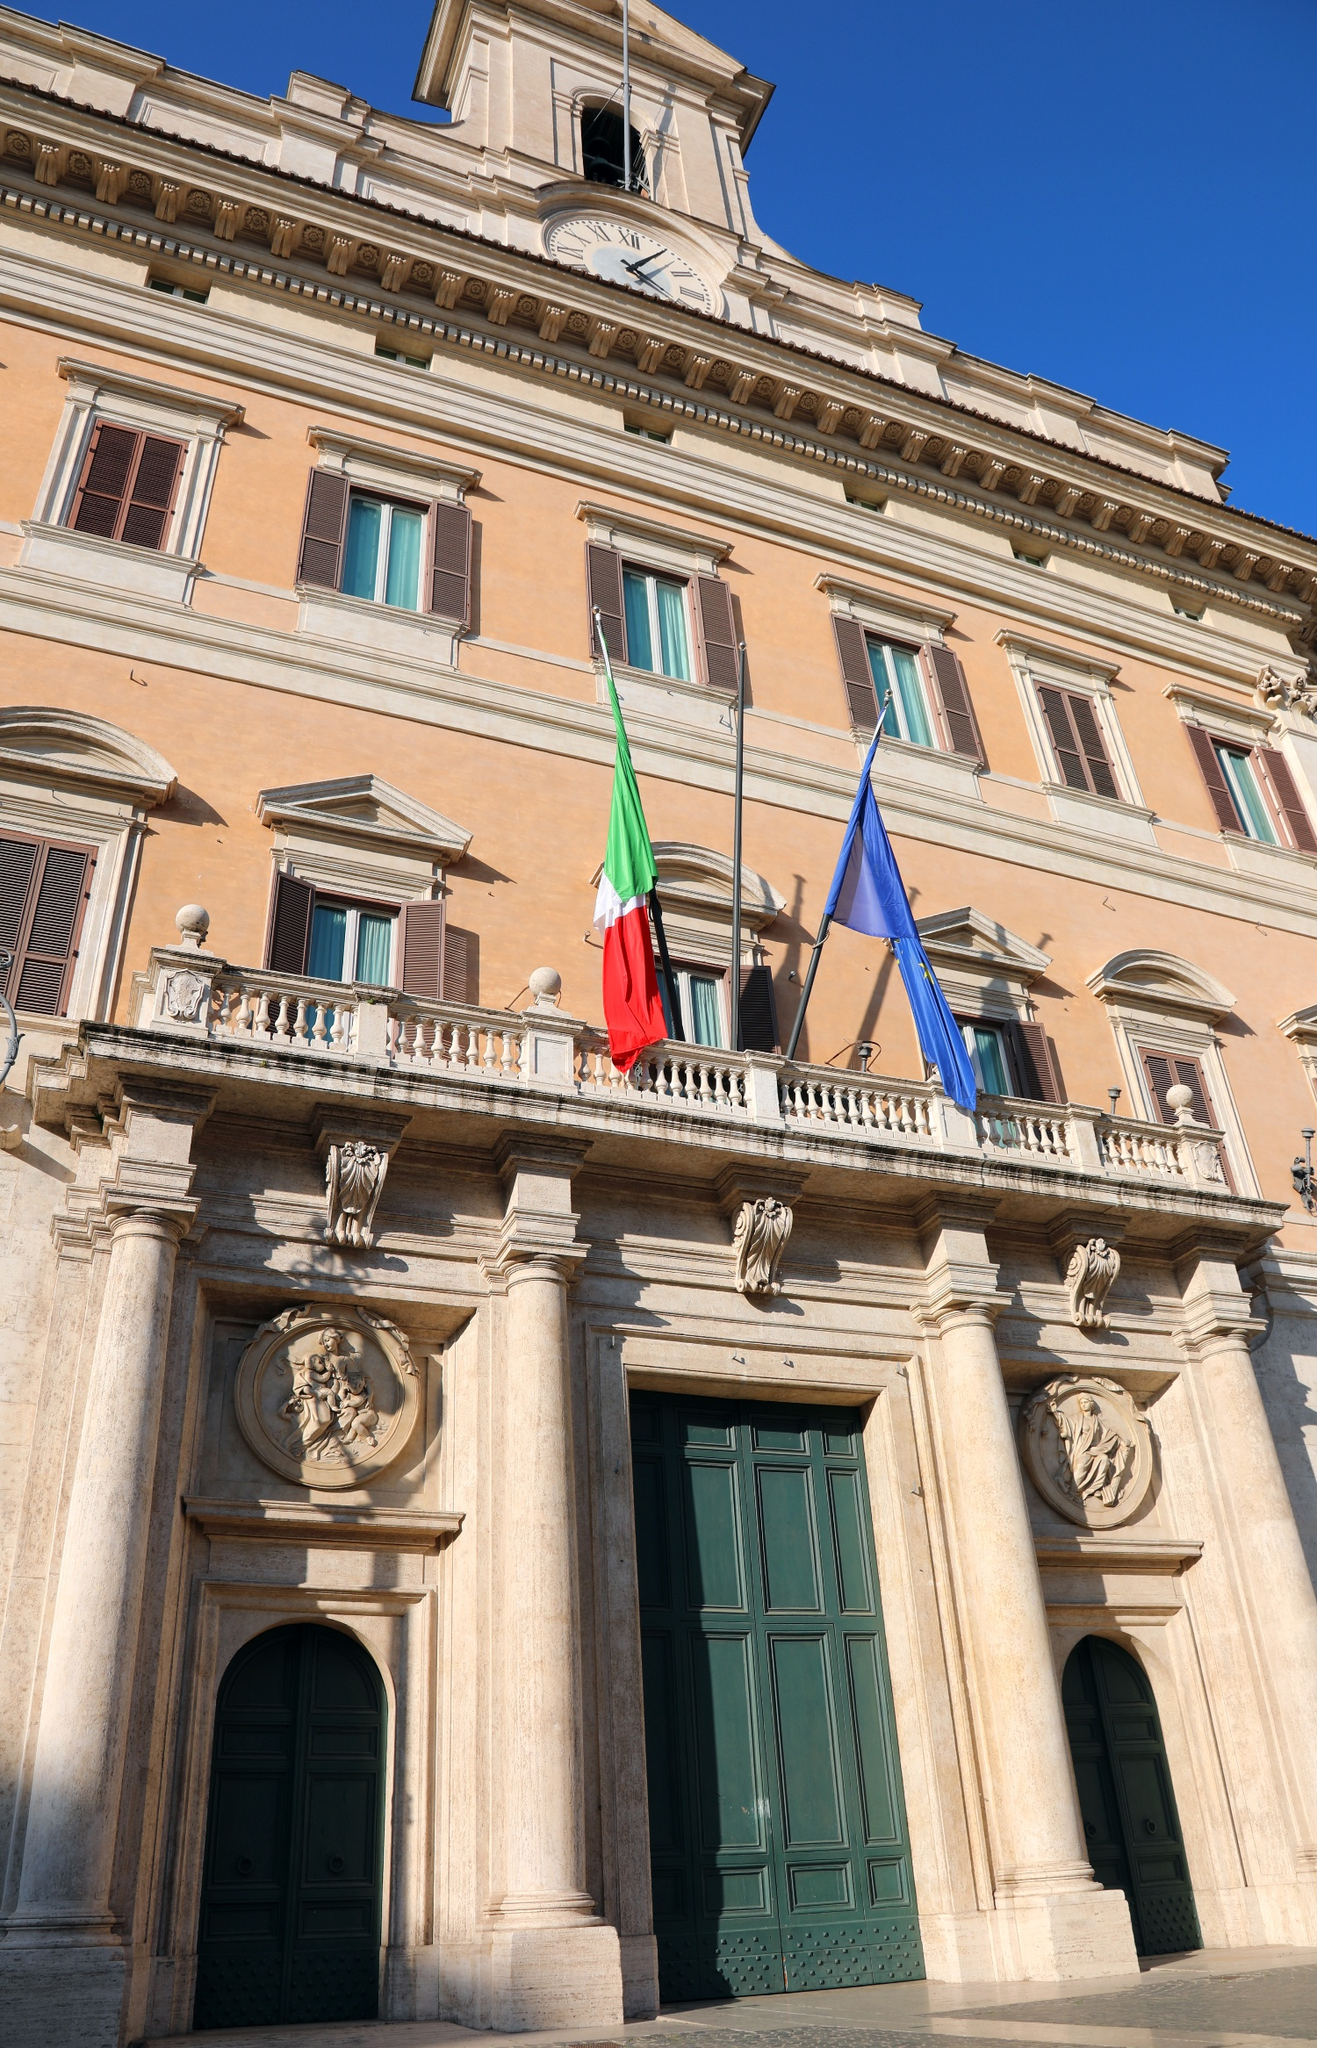Can you tell me about any historic events associated with this building? Certainly. Palazzo Montecitorio has been a witness to many significant events in Italian history. Originally designed by Gian Lorenzo Bernini and completed by Carlo Fontana in the late 17th century, it became the seat of the Italian Chamber of Deputies in 1871, shortly after the unification of Italy. Over the years, it has been the site of important political decisions, debates, and reforms that have shaped modern Italy. It stands as a symbol of Italian democracy and the continuous evolution of the country's political landscape. 